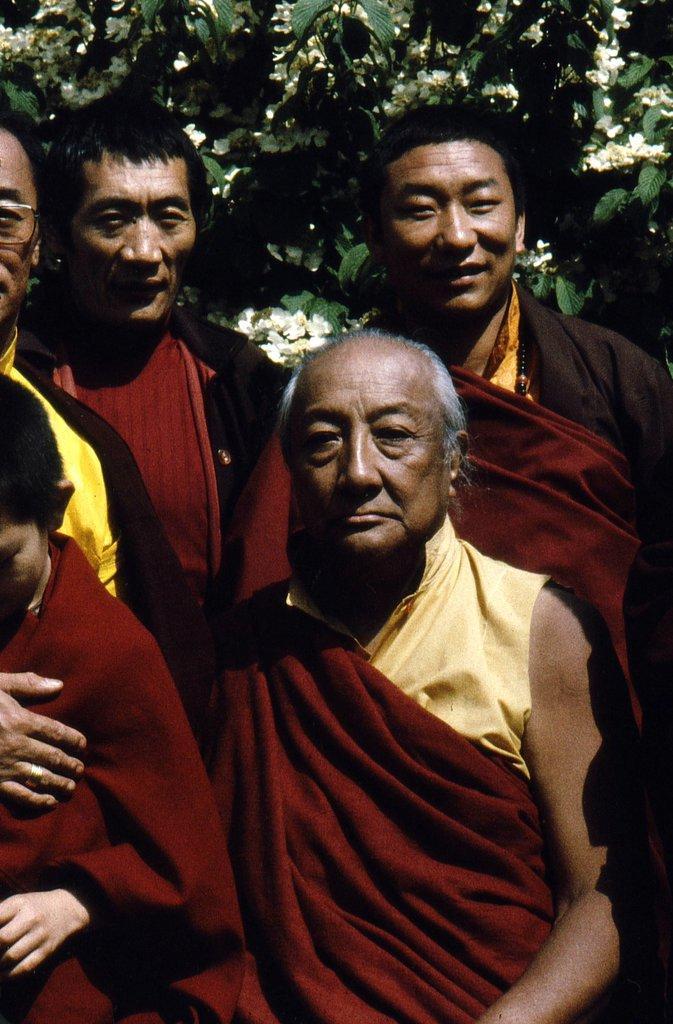Could you give a brief overview of what you see in this image? In this image we can see persons standing on the ground. In the background we can see tree with flowers. 